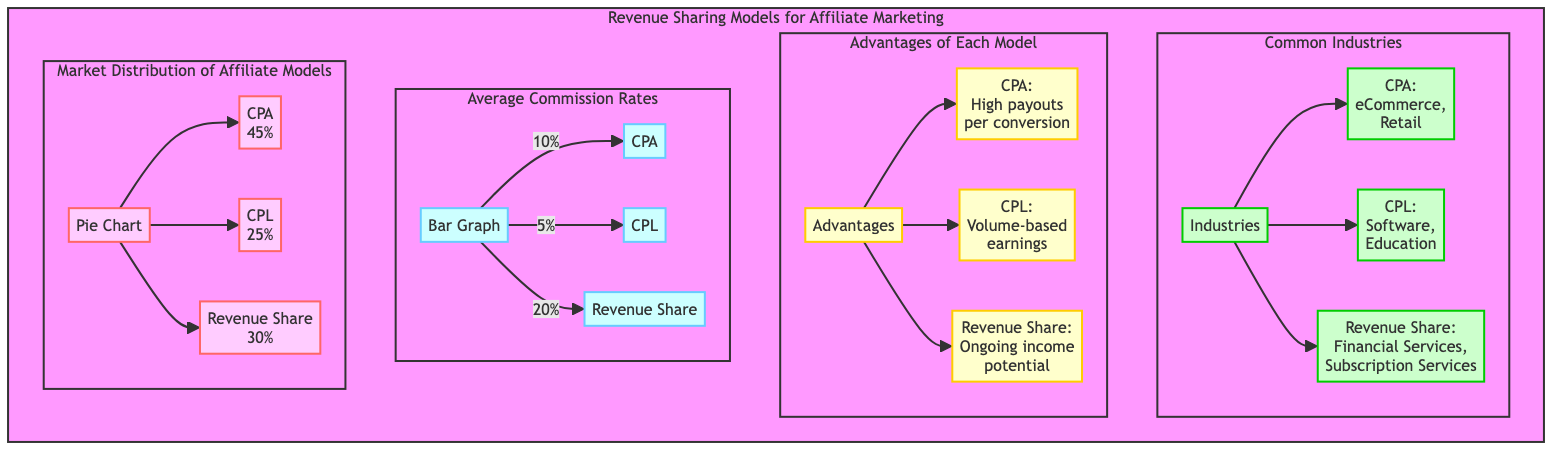What is the percentage distribution for CPA in the Revenue Sharing Models pie chart? In the pie chart, CPA is represented with a segment proportioning 45% of the total distribution of affiliate models, making it the highest of the three models depicted.
Answer: 45% What industries are commonly associated with Cost-Per-Lead? The diagram indicates that Cost-Per-Lead is commonly associated with two industries: Software and Education, which are explicitly mentioned in the section detailing common industries for each model.
Answer: Software, Education What is the average commission rate for Revenue Share according to the bar graph? The bar graph displays the average commission rates for different models, and Revenue Share is indicated at 20%, which shows it is the highest of the three models when compared to CPA and CPL.
Answer: 20% What is the major advantage of the Cost-Per-Acquisition model? According to the advantages section of the diagram, the key advantage for the CPA model is described as "High payouts per conversion," indicating that it rewards successful conversions significantly compared to the other models.
Answer: High payouts per conversion Which revenue sharing model provides ongoing income potential? In the advantages section, Revenue Share is highlighted as providing "Ongoing income potential," distinguishing it from the others by indicating a continuous earning opportunity in comparison to one-time payouts.
Answer: Revenue Share 